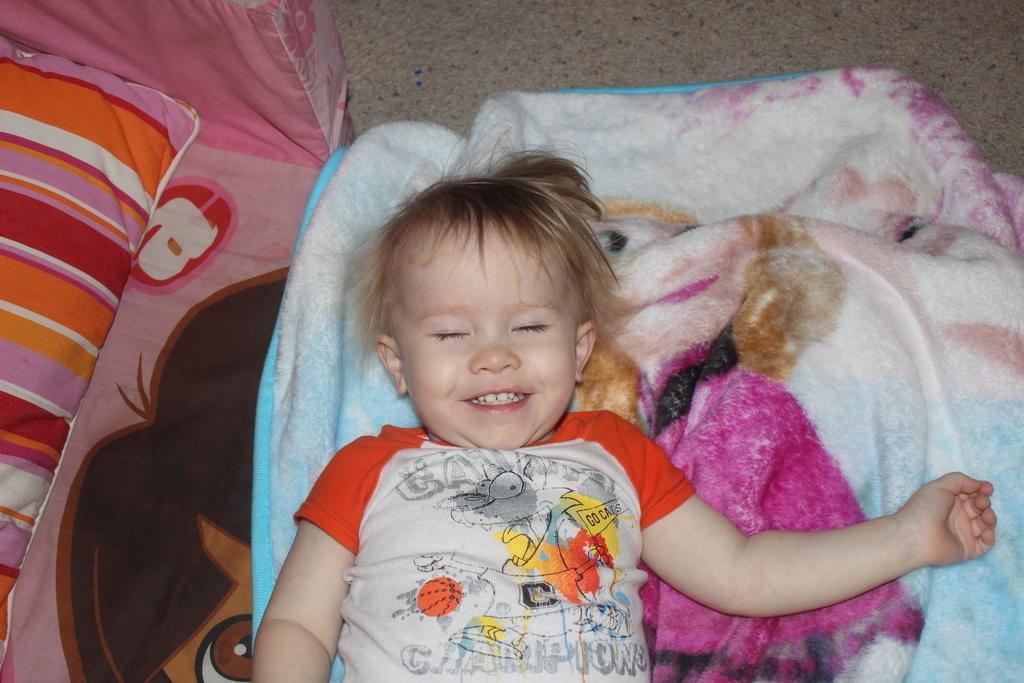What is the main subject of the picture? The main subject of the picture is a kid. What is the kid doing in the image? The kid is lying down and smiling. What can be seen at the bottom of the image? There is a cloth and a bed sheet at the bottom of the image. What is on the left side of the image? There is a pillow on the left side of the image. What type of legal advice is the kid providing in the image? There is no indication in the image that the kid is providing legal advice, as the image shows a kid lying down and smiling. What emotion is the kid expressing towards the hand in the image? There is no hand present in the image, and therefore no such interaction can be observed. 